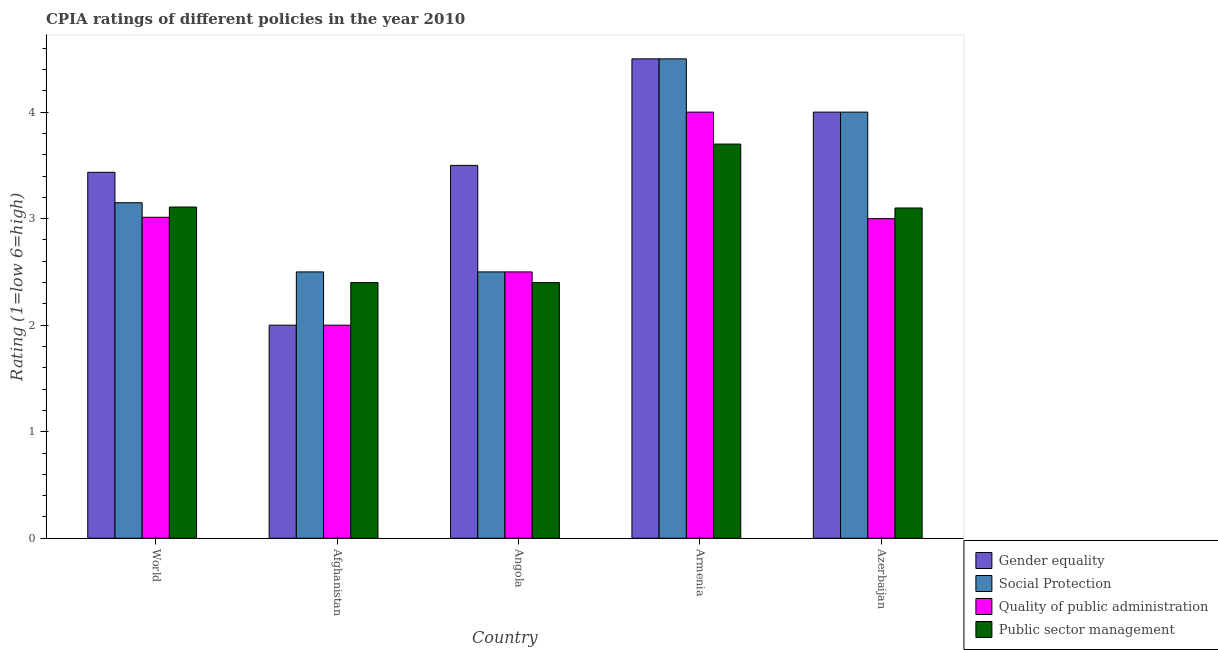How many different coloured bars are there?
Keep it short and to the point. 4. How many groups of bars are there?
Keep it short and to the point. 5. Are the number of bars per tick equal to the number of legend labels?
Keep it short and to the point. Yes. Are the number of bars on each tick of the X-axis equal?
Make the answer very short. Yes. How many bars are there on the 3rd tick from the left?
Offer a very short reply. 4. How many bars are there on the 2nd tick from the right?
Your response must be concise. 4. What is the cpia rating of social protection in World?
Offer a terse response. 3.15. Across all countries, what is the minimum cpia rating of public sector management?
Provide a succinct answer. 2.4. In which country was the cpia rating of quality of public administration maximum?
Your answer should be very brief. Armenia. In which country was the cpia rating of public sector management minimum?
Keep it short and to the point. Afghanistan. What is the total cpia rating of social protection in the graph?
Offer a very short reply. 16.65. What is the difference between the cpia rating of social protection in Afghanistan and that in World?
Your answer should be very brief. -0.65. What is the difference between the cpia rating of quality of public administration in Azerbaijan and the cpia rating of gender equality in World?
Your answer should be compact. -0.44. What is the average cpia rating of gender equality per country?
Your response must be concise. 3.49. What is the difference between the cpia rating of gender equality and cpia rating of public sector management in Armenia?
Your answer should be compact. 0.8. In how many countries, is the cpia rating of gender equality greater than 2.4 ?
Ensure brevity in your answer.  4. What is the ratio of the cpia rating of social protection in Angola to that in Azerbaijan?
Provide a succinct answer. 0.62. Is the cpia rating of gender equality in Armenia less than that in World?
Give a very brief answer. No. Is the difference between the cpia rating of public sector management in Angola and World greater than the difference between the cpia rating of gender equality in Angola and World?
Offer a terse response. No. What is the difference between the highest and the second highest cpia rating of public sector management?
Make the answer very short. 0.59. Is the sum of the cpia rating of social protection in Afghanistan and Armenia greater than the maximum cpia rating of public sector management across all countries?
Make the answer very short. Yes. Is it the case that in every country, the sum of the cpia rating of gender equality and cpia rating of public sector management is greater than the sum of cpia rating of social protection and cpia rating of quality of public administration?
Give a very brief answer. No. What does the 2nd bar from the left in Azerbaijan represents?
Make the answer very short. Social Protection. What does the 2nd bar from the right in Azerbaijan represents?
Give a very brief answer. Quality of public administration. How many bars are there?
Keep it short and to the point. 20. What is the difference between two consecutive major ticks on the Y-axis?
Make the answer very short. 1. Does the graph contain any zero values?
Ensure brevity in your answer.  No. Does the graph contain grids?
Your answer should be compact. No. How many legend labels are there?
Your answer should be compact. 4. How are the legend labels stacked?
Your answer should be compact. Vertical. What is the title of the graph?
Your response must be concise. CPIA ratings of different policies in the year 2010. What is the label or title of the X-axis?
Provide a succinct answer. Country. What is the label or title of the Y-axis?
Make the answer very short. Rating (1=low 6=high). What is the Rating (1=low 6=high) of Gender equality in World?
Your answer should be compact. 3.44. What is the Rating (1=low 6=high) in Social Protection in World?
Your answer should be compact. 3.15. What is the Rating (1=low 6=high) in Quality of public administration in World?
Provide a short and direct response. 3.01. What is the Rating (1=low 6=high) in Public sector management in World?
Your answer should be compact. 3.11. What is the Rating (1=low 6=high) in Public sector management in Afghanistan?
Make the answer very short. 2.4. What is the Rating (1=low 6=high) of Gender equality in Angola?
Provide a succinct answer. 3.5. What is the Rating (1=low 6=high) of Quality of public administration in Angola?
Offer a terse response. 2.5. What is the Rating (1=low 6=high) of Public sector management in Angola?
Provide a short and direct response. 2.4. What is the Rating (1=low 6=high) in Gender equality in Azerbaijan?
Provide a short and direct response. 4. What is the Rating (1=low 6=high) of Social Protection in Azerbaijan?
Your answer should be compact. 4. Across all countries, what is the maximum Rating (1=low 6=high) in Gender equality?
Your answer should be compact. 4.5. Across all countries, what is the maximum Rating (1=low 6=high) in Quality of public administration?
Your response must be concise. 4. Across all countries, what is the minimum Rating (1=low 6=high) of Gender equality?
Your response must be concise. 2. Across all countries, what is the minimum Rating (1=low 6=high) of Social Protection?
Give a very brief answer. 2.5. What is the total Rating (1=low 6=high) in Gender equality in the graph?
Your response must be concise. 17.44. What is the total Rating (1=low 6=high) of Social Protection in the graph?
Your answer should be very brief. 16.65. What is the total Rating (1=low 6=high) of Quality of public administration in the graph?
Provide a short and direct response. 14.51. What is the total Rating (1=low 6=high) in Public sector management in the graph?
Provide a succinct answer. 14.71. What is the difference between the Rating (1=low 6=high) of Gender equality in World and that in Afghanistan?
Give a very brief answer. 1.44. What is the difference between the Rating (1=low 6=high) of Social Protection in World and that in Afghanistan?
Provide a short and direct response. 0.65. What is the difference between the Rating (1=low 6=high) of Quality of public administration in World and that in Afghanistan?
Your answer should be compact. 1.01. What is the difference between the Rating (1=low 6=high) in Public sector management in World and that in Afghanistan?
Provide a succinct answer. 0.71. What is the difference between the Rating (1=low 6=high) of Gender equality in World and that in Angola?
Ensure brevity in your answer.  -0.06. What is the difference between the Rating (1=low 6=high) of Social Protection in World and that in Angola?
Offer a terse response. 0.65. What is the difference between the Rating (1=low 6=high) in Quality of public administration in World and that in Angola?
Keep it short and to the point. 0.51. What is the difference between the Rating (1=low 6=high) in Public sector management in World and that in Angola?
Provide a short and direct response. 0.71. What is the difference between the Rating (1=low 6=high) in Gender equality in World and that in Armenia?
Keep it short and to the point. -1.06. What is the difference between the Rating (1=low 6=high) in Social Protection in World and that in Armenia?
Make the answer very short. -1.35. What is the difference between the Rating (1=low 6=high) of Quality of public administration in World and that in Armenia?
Keep it short and to the point. -0.99. What is the difference between the Rating (1=low 6=high) of Public sector management in World and that in Armenia?
Give a very brief answer. -0.59. What is the difference between the Rating (1=low 6=high) of Gender equality in World and that in Azerbaijan?
Give a very brief answer. -0.56. What is the difference between the Rating (1=low 6=high) of Social Protection in World and that in Azerbaijan?
Make the answer very short. -0.85. What is the difference between the Rating (1=low 6=high) in Quality of public administration in World and that in Azerbaijan?
Make the answer very short. 0.01. What is the difference between the Rating (1=low 6=high) in Public sector management in World and that in Azerbaijan?
Provide a succinct answer. 0.01. What is the difference between the Rating (1=low 6=high) in Social Protection in Afghanistan and that in Angola?
Your response must be concise. 0. What is the difference between the Rating (1=low 6=high) of Quality of public administration in Afghanistan and that in Angola?
Your answer should be very brief. -0.5. What is the difference between the Rating (1=low 6=high) of Public sector management in Afghanistan and that in Angola?
Provide a succinct answer. 0. What is the difference between the Rating (1=low 6=high) of Social Protection in Afghanistan and that in Azerbaijan?
Ensure brevity in your answer.  -1.5. What is the difference between the Rating (1=low 6=high) of Public sector management in Afghanistan and that in Azerbaijan?
Ensure brevity in your answer.  -0.7. What is the difference between the Rating (1=low 6=high) in Gender equality in Angola and that in Armenia?
Ensure brevity in your answer.  -1. What is the difference between the Rating (1=low 6=high) in Social Protection in Angola and that in Armenia?
Give a very brief answer. -2. What is the difference between the Rating (1=low 6=high) of Social Protection in Angola and that in Azerbaijan?
Your answer should be compact. -1.5. What is the difference between the Rating (1=low 6=high) of Quality of public administration in Angola and that in Azerbaijan?
Your answer should be compact. -0.5. What is the difference between the Rating (1=low 6=high) in Public sector management in Angola and that in Azerbaijan?
Provide a short and direct response. -0.7. What is the difference between the Rating (1=low 6=high) of Social Protection in Armenia and that in Azerbaijan?
Make the answer very short. 0.5. What is the difference between the Rating (1=low 6=high) of Quality of public administration in Armenia and that in Azerbaijan?
Your answer should be compact. 1. What is the difference between the Rating (1=low 6=high) in Gender equality in World and the Rating (1=low 6=high) in Social Protection in Afghanistan?
Ensure brevity in your answer.  0.94. What is the difference between the Rating (1=low 6=high) of Gender equality in World and the Rating (1=low 6=high) of Quality of public administration in Afghanistan?
Keep it short and to the point. 1.44. What is the difference between the Rating (1=low 6=high) of Gender equality in World and the Rating (1=low 6=high) of Public sector management in Afghanistan?
Your response must be concise. 1.04. What is the difference between the Rating (1=low 6=high) in Social Protection in World and the Rating (1=low 6=high) in Quality of public administration in Afghanistan?
Ensure brevity in your answer.  1.15. What is the difference between the Rating (1=low 6=high) in Social Protection in World and the Rating (1=low 6=high) in Public sector management in Afghanistan?
Your answer should be very brief. 0.75. What is the difference between the Rating (1=low 6=high) of Quality of public administration in World and the Rating (1=low 6=high) of Public sector management in Afghanistan?
Offer a terse response. 0.61. What is the difference between the Rating (1=low 6=high) of Gender equality in World and the Rating (1=low 6=high) of Social Protection in Angola?
Make the answer very short. 0.94. What is the difference between the Rating (1=low 6=high) in Gender equality in World and the Rating (1=low 6=high) in Quality of public administration in Angola?
Your response must be concise. 0.94. What is the difference between the Rating (1=low 6=high) in Gender equality in World and the Rating (1=low 6=high) in Public sector management in Angola?
Provide a succinct answer. 1.04. What is the difference between the Rating (1=low 6=high) of Social Protection in World and the Rating (1=low 6=high) of Quality of public administration in Angola?
Provide a succinct answer. 0.65. What is the difference between the Rating (1=low 6=high) in Social Protection in World and the Rating (1=low 6=high) in Public sector management in Angola?
Your answer should be compact. 0.75. What is the difference between the Rating (1=low 6=high) of Quality of public administration in World and the Rating (1=low 6=high) of Public sector management in Angola?
Make the answer very short. 0.61. What is the difference between the Rating (1=low 6=high) in Gender equality in World and the Rating (1=low 6=high) in Social Protection in Armenia?
Offer a terse response. -1.06. What is the difference between the Rating (1=low 6=high) of Gender equality in World and the Rating (1=low 6=high) of Quality of public administration in Armenia?
Your answer should be very brief. -0.56. What is the difference between the Rating (1=low 6=high) in Gender equality in World and the Rating (1=low 6=high) in Public sector management in Armenia?
Your answer should be very brief. -0.26. What is the difference between the Rating (1=low 6=high) in Social Protection in World and the Rating (1=low 6=high) in Quality of public administration in Armenia?
Your answer should be compact. -0.85. What is the difference between the Rating (1=low 6=high) of Social Protection in World and the Rating (1=low 6=high) of Public sector management in Armenia?
Give a very brief answer. -0.55. What is the difference between the Rating (1=low 6=high) of Quality of public administration in World and the Rating (1=low 6=high) of Public sector management in Armenia?
Give a very brief answer. -0.69. What is the difference between the Rating (1=low 6=high) in Gender equality in World and the Rating (1=low 6=high) in Social Protection in Azerbaijan?
Offer a very short reply. -0.56. What is the difference between the Rating (1=low 6=high) in Gender equality in World and the Rating (1=low 6=high) in Quality of public administration in Azerbaijan?
Keep it short and to the point. 0.44. What is the difference between the Rating (1=low 6=high) of Gender equality in World and the Rating (1=low 6=high) of Public sector management in Azerbaijan?
Keep it short and to the point. 0.34. What is the difference between the Rating (1=low 6=high) in Social Protection in World and the Rating (1=low 6=high) in Quality of public administration in Azerbaijan?
Keep it short and to the point. 0.15. What is the difference between the Rating (1=low 6=high) in Social Protection in World and the Rating (1=low 6=high) in Public sector management in Azerbaijan?
Provide a succinct answer. 0.05. What is the difference between the Rating (1=low 6=high) in Quality of public administration in World and the Rating (1=low 6=high) in Public sector management in Azerbaijan?
Provide a short and direct response. -0.09. What is the difference between the Rating (1=low 6=high) in Gender equality in Afghanistan and the Rating (1=low 6=high) in Public sector management in Angola?
Your answer should be compact. -0.4. What is the difference between the Rating (1=low 6=high) in Gender equality in Afghanistan and the Rating (1=low 6=high) in Quality of public administration in Armenia?
Give a very brief answer. -2. What is the difference between the Rating (1=low 6=high) of Social Protection in Afghanistan and the Rating (1=low 6=high) of Public sector management in Armenia?
Give a very brief answer. -1.2. What is the difference between the Rating (1=low 6=high) of Quality of public administration in Afghanistan and the Rating (1=low 6=high) of Public sector management in Armenia?
Keep it short and to the point. -1.7. What is the difference between the Rating (1=low 6=high) of Gender equality in Afghanistan and the Rating (1=low 6=high) of Quality of public administration in Azerbaijan?
Your answer should be compact. -1. What is the difference between the Rating (1=low 6=high) of Social Protection in Afghanistan and the Rating (1=low 6=high) of Quality of public administration in Azerbaijan?
Your answer should be very brief. -0.5. What is the difference between the Rating (1=low 6=high) of Social Protection in Afghanistan and the Rating (1=low 6=high) of Public sector management in Azerbaijan?
Provide a succinct answer. -0.6. What is the difference between the Rating (1=low 6=high) of Gender equality in Angola and the Rating (1=low 6=high) of Social Protection in Armenia?
Give a very brief answer. -1. What is the difference between the Rating (1=low 6=high) of Gender equality in Angola and the Rating (1=low 6=high) of Public sector management in Armenia?
Ensure brevity in your answer.  -0.2. What is the difference between the Rating (1=low 6=high) in Social Protection in Angola and the Rating (1=low 6=high) in Quality of public administration in Armenia?
Keep it short and to the point. -1.5. What is the difference between the Rating (1=low 6=high) in Social Protection in Angola and the Rating (1=low 6=high) in Public sector management in Armenia?
Give a very brief answer. -1.2. What is the difference between the Rating (1=low 6=high) of Gender equality in Angola and the Rating (1=low 6=high) of Public sector management in Azerbaijan?
Your answer should be very brief. 0.4. What is the difference between the Rating (1=low 6=high) of Gender equality in Armenia and the Rating (1=low 6=high) of Quality of public administration in Azerbaijan?
Make the answer very short. 1.5. What is the difference between the Rating (1=low 6=high) of Quality of public administration in Armenia and the Rating (1=low 6=high) of Public sector management in Azerbaijan?
Give a very brief answer. 0.9. What is the average Rating (1=low 6=high) in Gender equality per country?
Provide a short and direct response. 3.49. What is the average Rating (1=low 6=high) in Social Protection per country?
Offer a terse response. 3.33. What is the average Rating (1=low 6=high) in Quality of public administration per country?
Provide a succinct answer. 2.9. What is the average Rating (1=low 6=high) of Public sector management per country?
Give a very brief answer. 2.94. What is the difference between the Rating (1=low 6=high) of Gender equality and Rating (1=low 6=high) of Social Protection in World?
Ensure brevity in your answer.  0.29. What is the difference between the Rating (1=low 6=high) of Gender equality and Rating (1=low 6=high) of Quality of public administration in World?
Your answer should be very brief. 0.42. What is the difference between the Rating (1=low 6=high) of Gender equality and Rating (1=low 6=high) of Public sector management in World?
Your answer should be very brief. 0.33. What is the difference between the Rating (1=low 6=high) in Social Protection and Rating (1=low 6=high) in Quality of public administration in World?
Provide a short and direct response. 0.14. What is the difference between the Rating (1=low 6=high) in Social Protection and Rating (1=low 6=high) in Public sector management in World?
Give a very brief answer. 0.04. What is the difference between the Rating (1=low 6=high) in Quality of public administration and Rating (1=low 6=high) in Public sector management in World?
Your answer should be very brief. -0.1. What is the difference between the Rating (1=low 6=high) of Gender equality and Rating (1=low 6=high) of Public sector management in Afghanistan?
Your response must be concise. -0.4. What is the difference between the Rating (1=low 6=high) of Social Protection and Rating (1=low 6=high) of Quality of public administration in Afghanistan?
Your answer should be very brief. 0.5. What is the difference between the Rating (1=low 6=high) in Social Protection and Rating (1=low 6=high) in Public sector management in Afghanistan?
Provide a short and direct response. 0.1. What is the difference between the Rating (1=low 6=high) in Gender equality and Rating (1=low 6=high) in Social Protection in Angola?
Keep it short and to the point. 1. What is the difference between the Rating (1=low 6=high) of Gender equality and Rating (1=low 6=high) of Public sector management in Angola?
Your response must be concise. 1.1. What is the difference between the Rating (1=low 6=high) in Social Protection and Rating (1=low 6=high) in Quality of public administration in Angola?
Keep it short and to the point. 0. What is the difference between the Rating (1=low 6=high) of Social Protection and Rating (1=low 6=high) of Public sector management in Angola?
Your answer should be very brief. 0.1. What is the difference between the Rating (1=low 6=high) of Gender equality and Rating (1=low 6=high) of Social Protection in Armenia?
Provide a short and direct response. 0. What is the difference between the Rating (1=low 6=high) of Gender equality and Rating (1=low 6=high) of Quality of public administration in Armenia?
Make the answer very short. 0.5. What is the difference between the Rating (1=low 6=high) in Gender equality and Rating (1=low 6=high) in Public sector management in Armenia?
Ensure brevity in your answer.  0.8. What is the difference between the Rating (1=low 6=high) of Gender equality and Rating (1=low 6=high) of Quality of public administration in Azerbaijan?
Offer a terse response. 1. What is the difference between the Rating (1=low 6=high) of Gender equality and Rating (1=low 6=high) of Public sector management in Azerbaijan?
Give a very brief answer. 0.9. What is the difference between the Rating (1=low 6=high) in Social Protection and Rating (1=low 6=high) in Quality of public administration in Azerbaijan?
Give a very brief answer. 1. What is the difference between the Rating (1=low 6=high) of Social Protection and Rating (1=low 6=high) of Public sector management in Azerbaijan?
Ensure brevity in your answer.  0.9. What is the ratio of the Rating (1=low 6=high) of Gender equality in World to that in Afghanistan?
Make the answer very short. 1.72. What is the ratio of the Rating (1=low 6=high) in Social Protection in World to that in Afghanistan?
Your answer should be very brief. 1.26. What is the ratio of the Rating (1=low 6=high) in Quality of public administration in World to that in Afghanistan?
Your answer should be compact. 1.51. What is the ratio of the Rating (1=low 6=high) in Public sector management in World to that in Afghanistan?
Your response must be concise. 1.3. What is the ratio of the Rating (1=low 6=high) of Gender equality in World to that in Angola?
Your answer should be very brief. 0.98. What is the ratio of the Rating (1=low 6=high) in Social Protection in World to that in Angola?
Make the answer very short. 1.26. What is the ratio of the Rating (1=low 6=high) of Quality of public administration in World to that in Angola?
Give a very brief answer. 1.21. What is the ratio of the Rating (1=low 6=high) of Public sector management in World to that in Angola?
Offer a terse response. 1.3. What is the ratio of the Rating (1=low 6=high) of Gender equality in World to that in Armenia?
Your response must be concise. 0.76. What is the ratio of the Rating (1=low 6=high) of Social Protection in World to that in Armenia?
Your response must be concise. 0.7. What is the ratio of the Rating (1=low 6=high) of Quality of public administration in World to that in Armenia?
Offer a terse response. 0.75. What is the ratio of the Rating (1=low 6=high) of Public sector management in World to that in Armenia?
Ensure brevity in your answer.  0.84. What is the ratio of the Rating (1=low 6=high) in Gender equality in World to that in Azerbaijan?
Keep it short and to the point. 0.86. What is the ratio of the Rating (1=low 6=high) in Social Protection in World to that in Azerbaijan?
Make the answer very short. 0.79. What is the ratio of the Rating (1=low 6=high) of Quality of public administration in World to that in Azerbaijan?
Keep it short and to the point. 1. What is the ratio of the Rating (1=low 6=high) of Public sector management in World to that in Azerbaijan?
Give a very brief answer. 1. What is the ratio of the Rating (1=low 6=high) in Social Protection in Afghanistan to that in Angola?
Keep it short and to the point. 1. What is the ratio of the Rating (1=low 6=high) in Quality of public administration in Afghanistan to that in Angola?
Your answer should be very brief. 0.8. What is the ratio of the Rating (1=low 6=high) of Public sector management in Afghanistan to that in Angola?
Provide a short and direct response. 1. What is the ratio of the Rating (1=low 6=high) of Gender equality in Afghanistan to that in Armenia?
Ensure brevity in your answer.  0.44. What is the ratio of the Rating (1=low 6=high) in Social Protection in Afghanistan to that in Armenia?
Keep it short and to the point. 0.56. What is the ratio of the Rating (1=low 6=high) in Public sector management in Afghanistan to that in Armenia?
Your answer should be very brief. 0.65. What is the ratio of the Rating (1=low 6=high) of Quality of public administration in Afghanistan to that in Azerbaijan?
Keep it short and to the point. 0.67. What is the ratio of the Rating (1=low 6=high) in Public sector management in Afghanistan to that in Azerbaijan?
Make the answer very short. 0.77. What is the ratio of the Rating (1=low 6=high) of Social Protection in Angola to that in Armenia?
Make the answer very short. 0.56. What is the ratio of the Rating (1=low 6=high) in Public sector management in Angola to that in Armenia?
Your answer should be compact. 0.65. What is the ratio of the Rating (1=low 6=high) of Gender equality in Angola to that in Azerbaijan?
Provide a succinct answer. 0.88. What is the ratio of the Rating (1=low 6=high) of Social Protection in Angola to that in Azerbaijan?
Your response must be concise. 0.62. What is the ratio of the Rating (1=low 6=high) in Public sector management in Angola to that in Azerbaijan?
Ensure brevity in your answer.  0.77. What is the ratio of the Rating (1=low 6=high) in Social Protection in Armenia to that in Azerbaijan?
Ensure brevity in your answer.  1.12. What is the ratio of the Rating (1=low 6=high) in Quality of public administration in Armenia to that in Azerbaijan?
Your answer should be very brief. 1.33. What is the ratio of the Rating (1=low 6=high) in Public sector management in Armenia to that in Azerbaijan?
Ensure brevity in your answer.  1.19. What is the difference between the highest and the second highest Rating (1=low 6=high) in Gender equality?
Offer a very short reply. 0.5. What is the difference between the highest and the second highest Rating (1=low 6=high) of Social Protection?
Provide a succinct answer. 0.5. What is the difference between the highest and the second highest Rating (1=low 6=high) of Public sector management?
Offer a very short reply. 0.59. What is the difference between the highest and the lowest Rating (1=low 6=high) in Gender equality?
Make the answer very short. 2.5. 